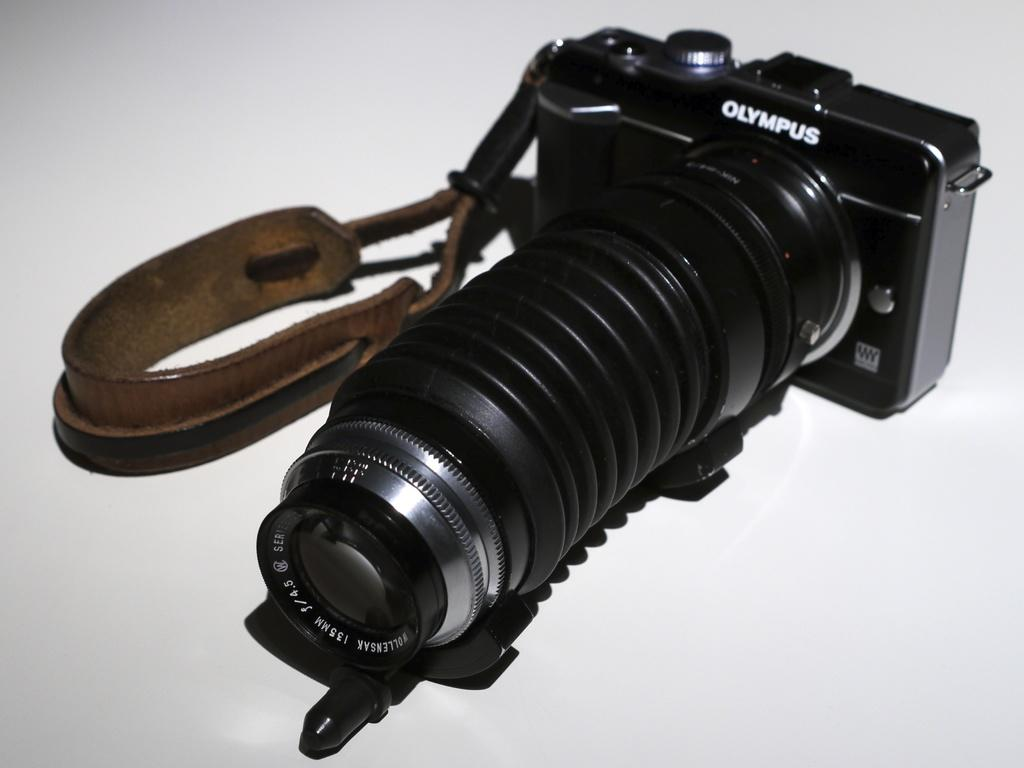What is the main object in the image? There is a camera in the image. What is attached to the camera? The camera has a belt. What is the color of the platform the camera is on? The platform the camera is on is white in color. Can you tell me what the secretary is doing in the image? There is no secretary present in the image; it only features a camera with a belt on a white platform. 